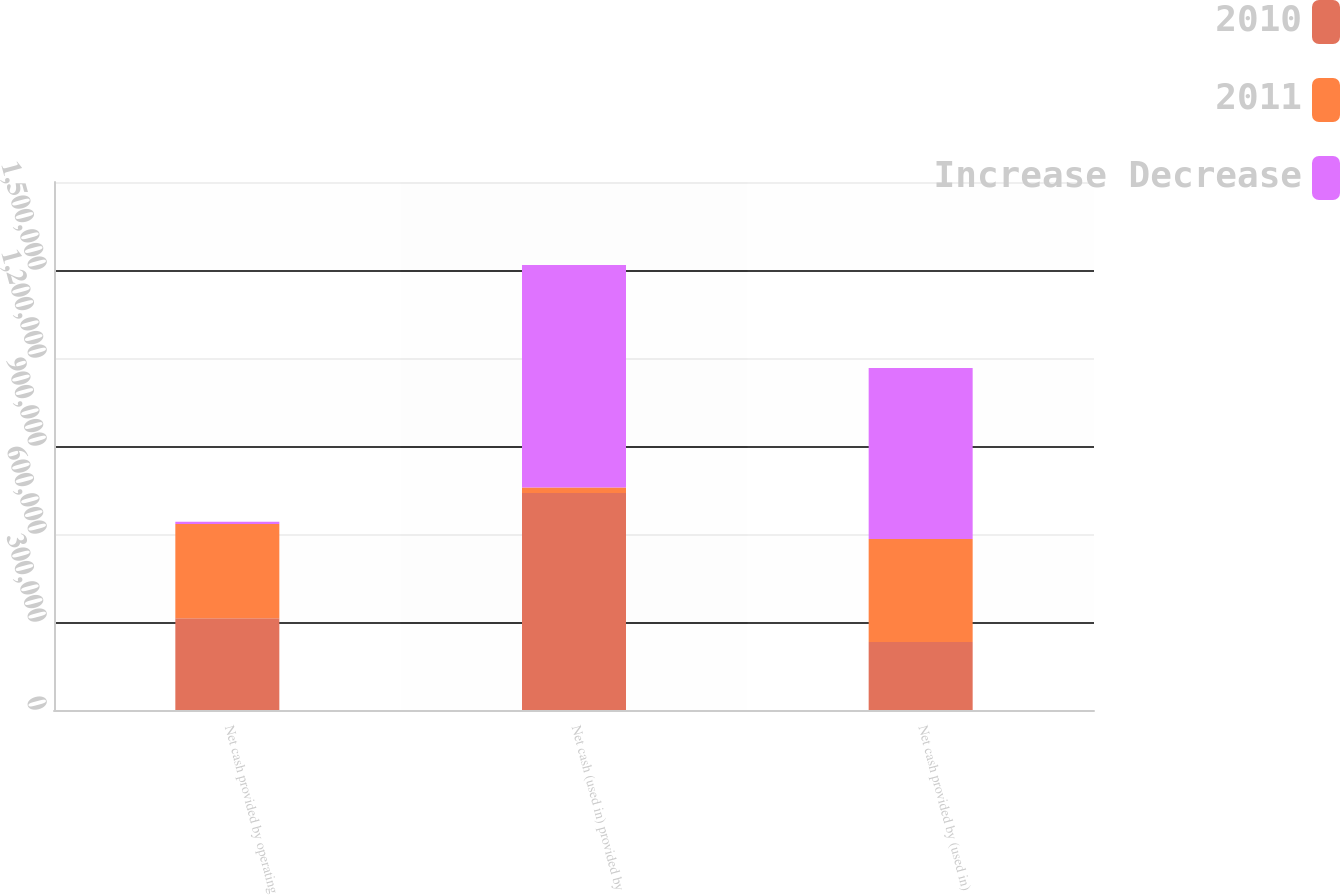<chart> <loc_0><loc_0><loc_500><loc_500><stacked_bar_chart><ecel><fcel>Net cash provided by operating<fcel>Net cash (used in) provided by<fcel>Net cash provided by (used in)<nl><fcel>2010<fcel>312860<fcel>739597<fcel>232099<nl><fcel>2011<fcel>321058<fcel>18815<fcel>350758<nl><fcel>Increase Decrease<fcel>8198<fcel>758412<fcel>582857<nl></chart> 